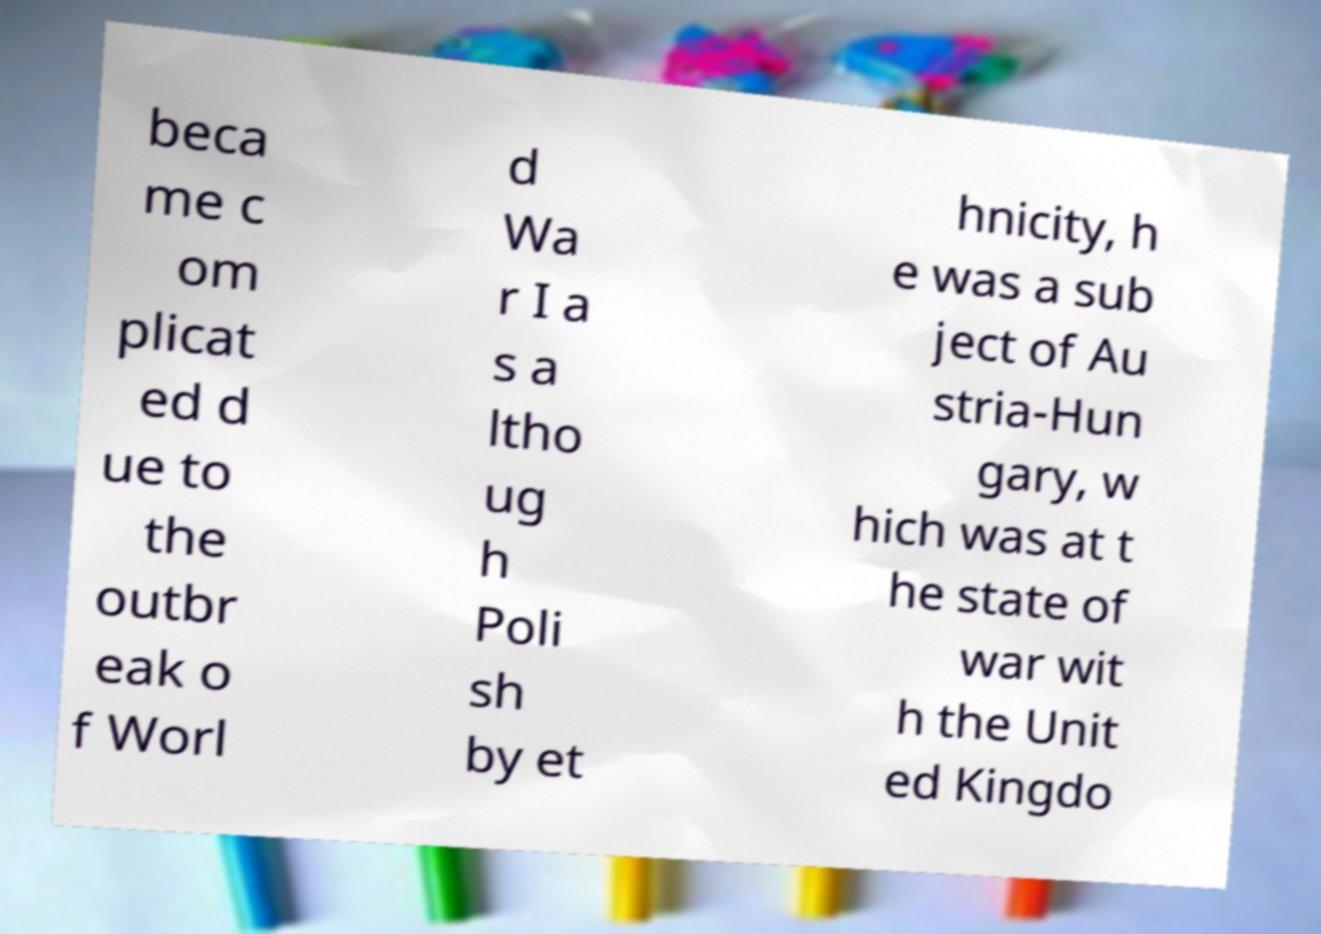Please read and relay the text visible in this image. What does it say? beca me c om plicat ed d ue to the outbr eak o f Worl d Wa r I a s a ltho ug h Poli sh by et hnicity, h e was a sub ject of Au stria-Hun gary, w hich was at t he state of war wit h the Unit ed Kingdo 